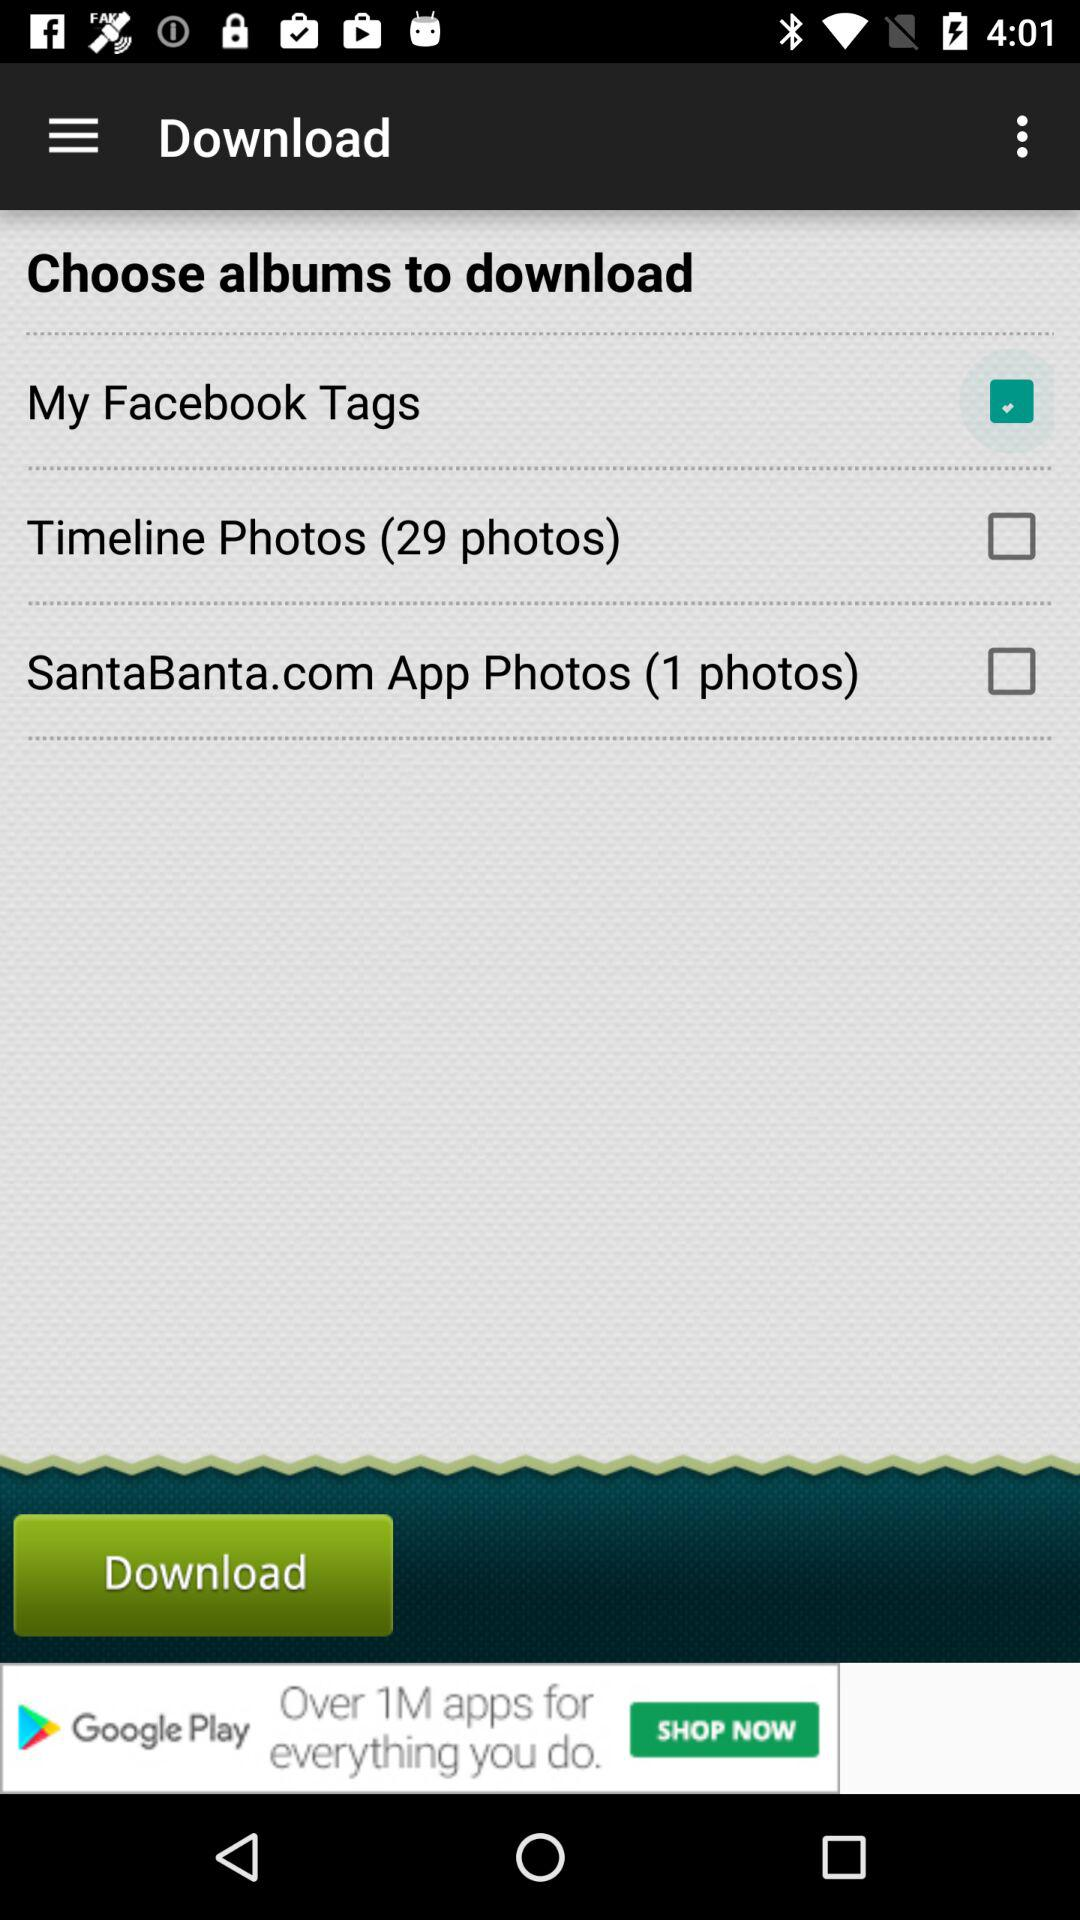How many photos are in the "SantaBanta.com App Photos" option? There is 1 photo. 